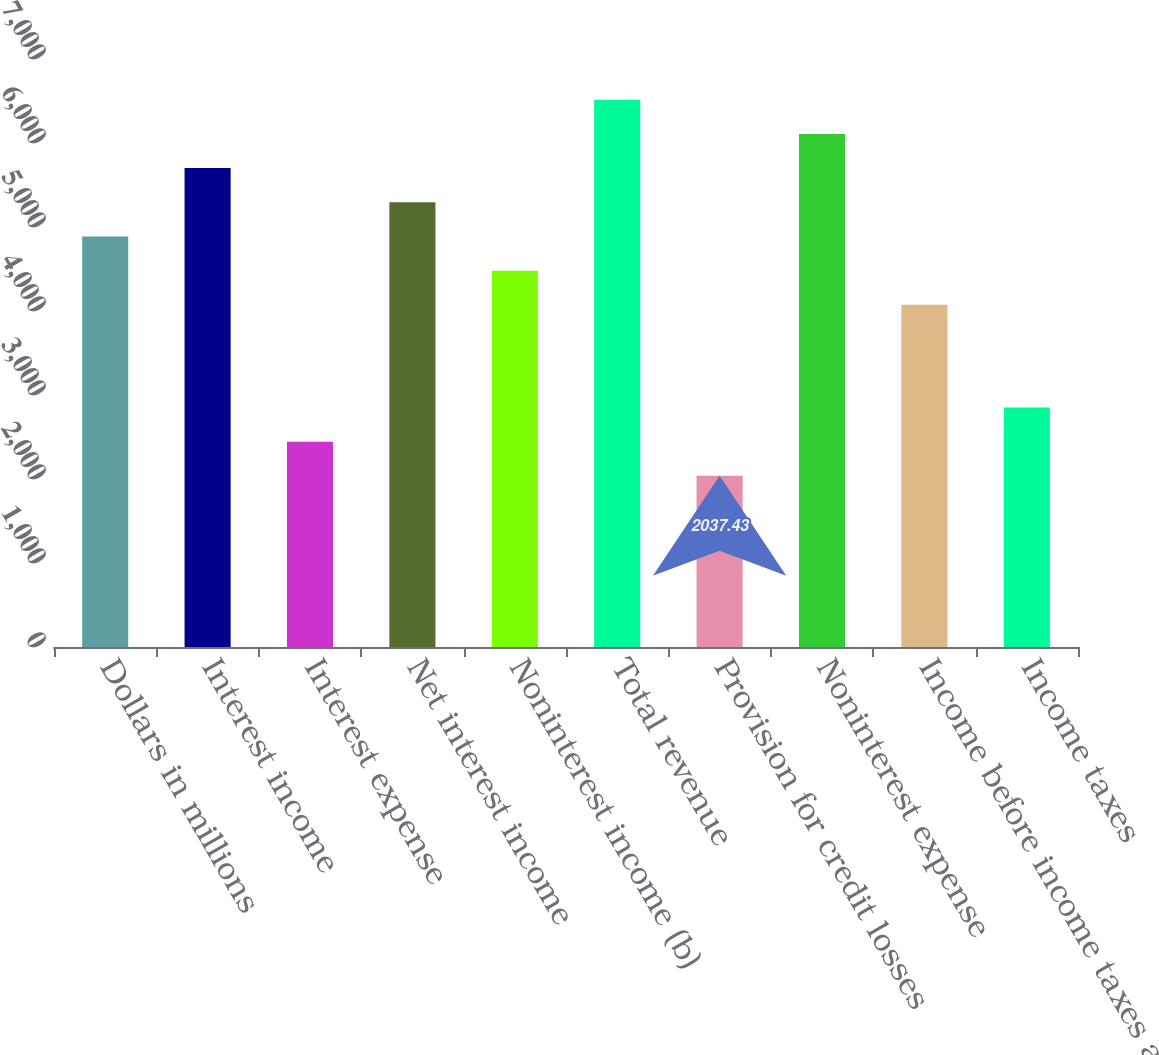Convert chart to OTSL. <chart><loc_0><loc_0><loc_500><loc_500><bar_chart><fcel>Dollars in millions<fcel>Interest income<fcel>Interest expense<fcel>Net interest income<fcel>Noninterest income (b)<fcel>Total revenue<fcel>Provision for credit losses<fcel>Noninterest expense<fcel>Income before income taxes and<fcel>Income taxes<nl><fcel>4887.23<fcel>5701.45<fcel>2444.55<fcel>5294.34<fcel>4480.12<fcel>6515.68<fcel>2037.43<fcel>6108.56<fcel>4073.01<fcel>2851.66<nl></chart> 